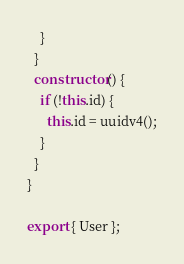<code> <loc_0><loc_0><loc_500><loc_500><_TypeScript_>    }
  }
  constructor() {
    if (!this.id) {
      this.id = uuidv4();
    }
  }
}

export { User };
</code> 